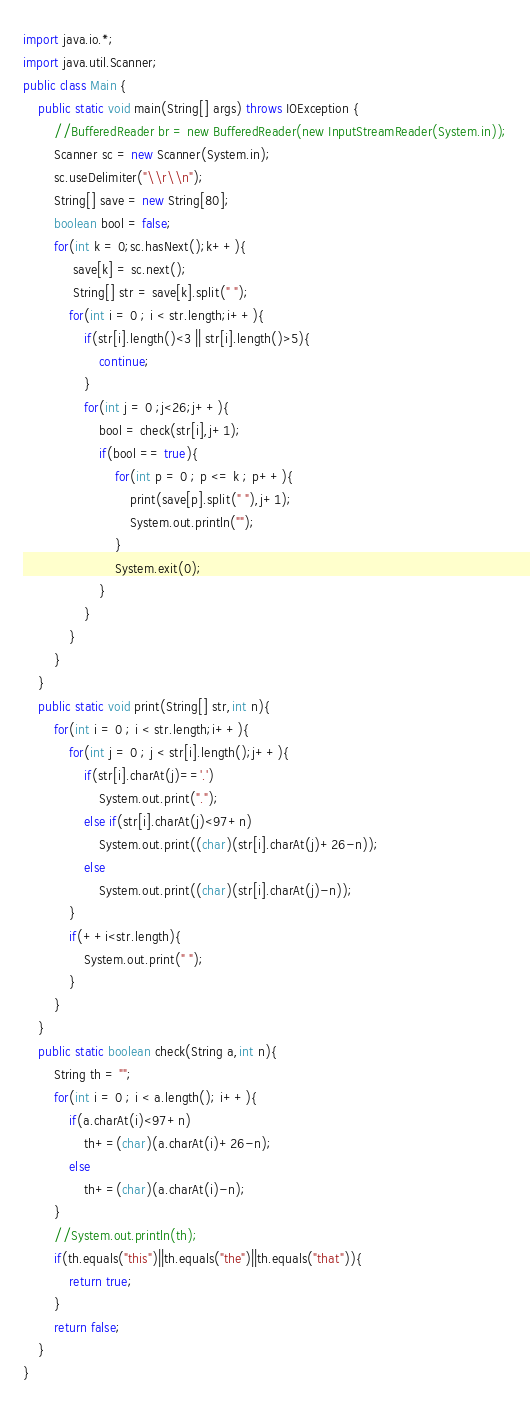<code> <loc_0><loc_0><loc_500><loc_500><_Java_>import java.io.*;
import java.util.Scanner;
public class Main {
    public static void main(String[] args) throws IOException {
        //BufferedReader br = new BufferedReader(new InputStreamReader(System.in));
    	Scanner sc = new Scanner(System.in);
    	sc.useDelimiter("\\r\\n");
    	String[] save = new String[80];
        boolean bool = false;
        for(int k = 0;sc.hasNext();k++){
        	 save[k] = sc.next();
             String[] str = save[k].split(" ");
	        for(int i = 0 ; i < str.length;i++){
	            if(str[i].length()<3 || str[i].length()>5){
	                continue;
	            }
	            for(int j = 0 ;j<26;j++){
	                bool = check(str[i],j+1);
	                if(bool == true){
	                	for(int p = 0 ; p <= k ; p++){
	                		print(save[p].split(" "),j+1);
	                		System.out.println("");
	                	}
	                	System.exit(0);
	                }
	            }
	        }
  		}
    }
    public static void print(String[] str,int n){
        for(int i = 0 ; i < str.length;i++){
            for(int j = 0 ; j < str[i].length();j++){
                if(str[i].charAt(j)=='.')
                    System.out.print(".");
                else if(str[i].charAt(j)<97+n)
                    System.out.print((char)(str[i].charAt(j)+26-n));
                else
                    System.out.print((char)(str[i].charAt(j)-n));
            }
            if(++i<str.length){
            	System.out.print(" ");
            }
        }
    }
    public static boolean check(String a,int n){
        String th = "";
        for(int i = 0 ; i < a.length(); i++){
            if(a.charAt(i)<97+n)
                th+=(char)(a.charAt(i)+26-n);
            else
                th+=(char)(a.charAt(i)-n);
        }
        //System.out.println(th);
        if(th.equals("this")||th.equals("the")||th.equals("that")){
            return true;
        }
        return false;
    }
}</code> 